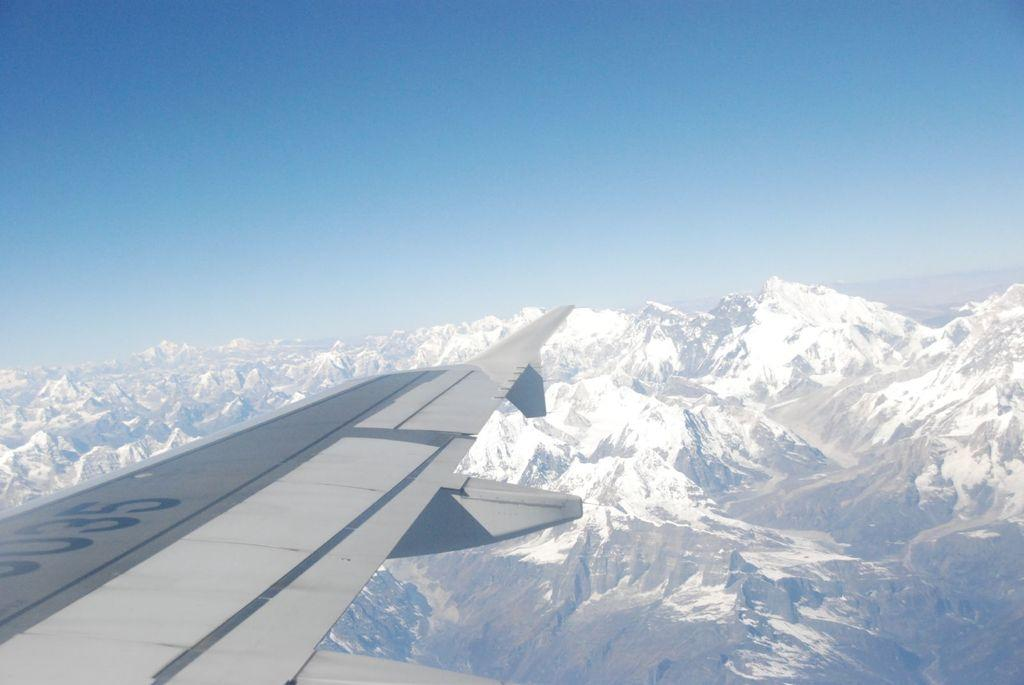<image>
Write a terse but informative summary of the picture. An airplane wing in the clouds that says 035 on it. 